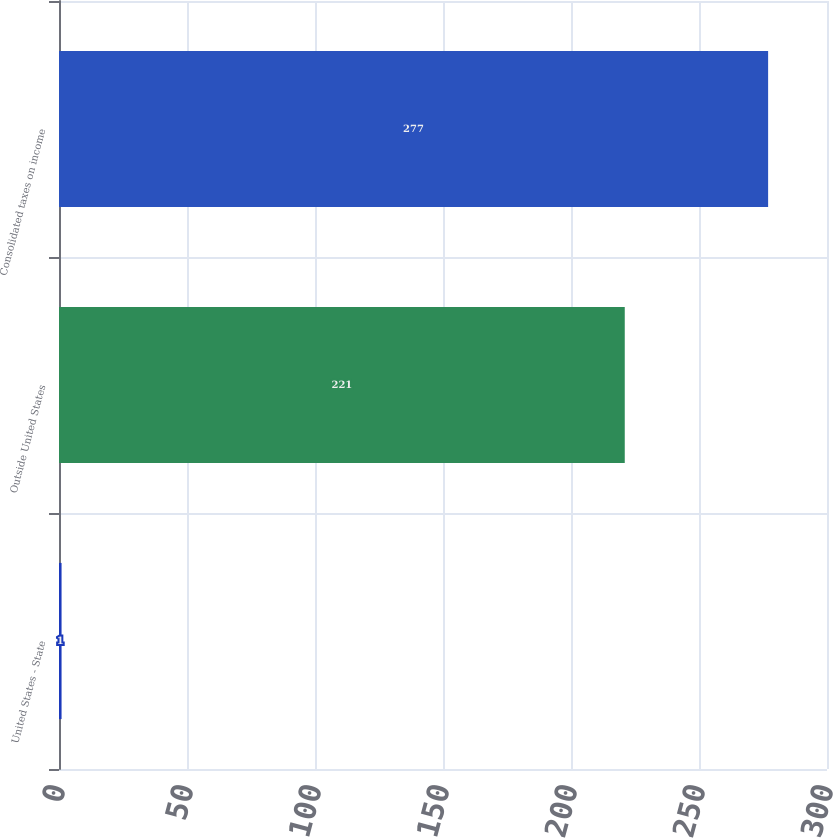Convert chart to OTSL. <chart><loc_0><loc_0><loc_500><loc_500><bar_chart><fcel>United States - State<fcel>Outside United States<fcel>Consolidated taxes on income<nl><fcel>1<fcel>221<fcel>277<nl></chart> 